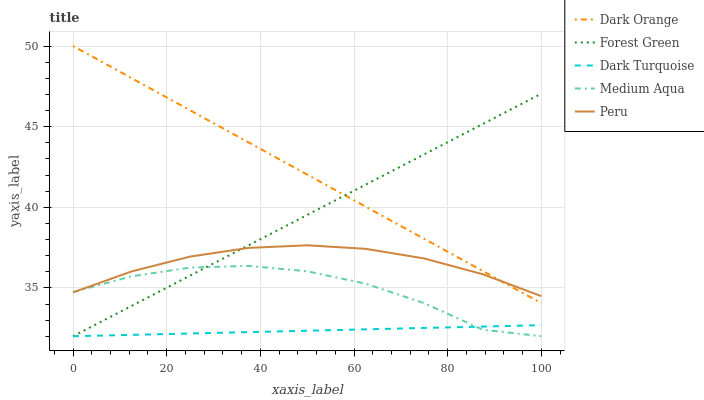Does Dark Turquoise have the minimum area under the curve?
Answer yes or no. Yes. Does Dark Orange have the maximum area under the curve?
Answer yes or no. Yes. Does Forest Green have the minimum area under the curve?
Answer yes or no. No. Does Forest Green have the maximum area under the curve?
Answer yes or no. No. Is Dark Orange the smoothest?
Answer yes or no. Yes. Is Medium Aqua the roughest?
Answer yes or no. Yes. Is Forest Green the smoothest?
Answer yes or no. No. Is Forest Green the roughest?
Answer yes or no. No. Does Peru have the lowest value?
Answer yes or no. No. Does Forest Green have the highest value?
Answer yes or no. No. Is Dark Turquoise less than Peru?
Answer yes or no. Yes. Is Peru greater than Dark Turquoise?
Answer yes or no. Yes. Does Dark Turquoise intersect Peru?
Answer yes or no. No. 